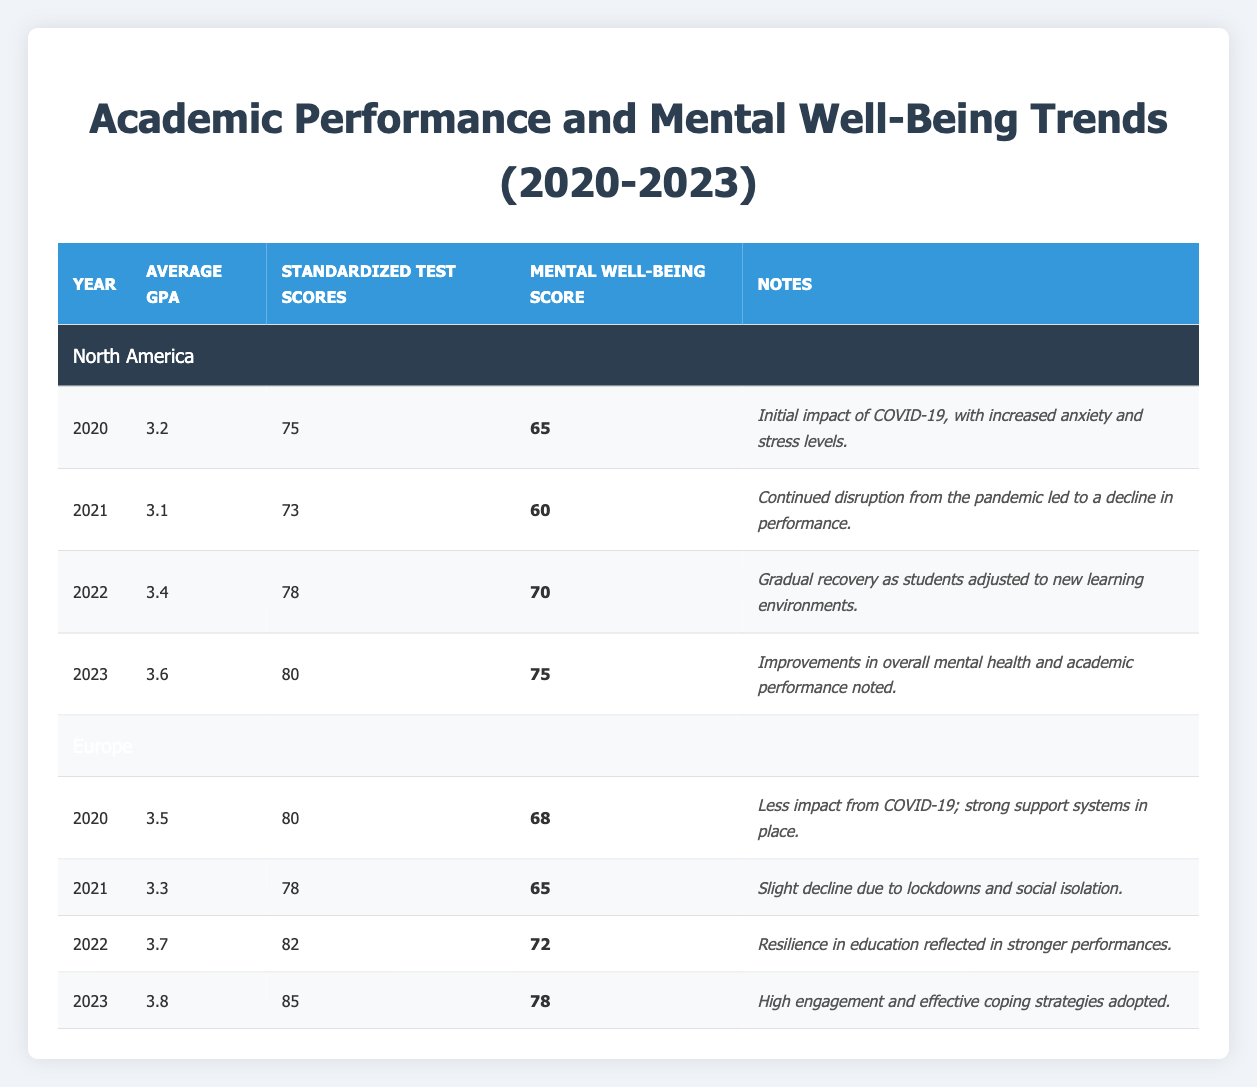What was the Average GPA in Europe in 2021? The table shows that in Europe, the Average GPA for the year 2021 is 3.3. This value can be directly retrieved from the row corresponding to the year 2021 in Europe.
Answer: 3.3 What is the difference in Standardized Test Scores between North America in 2020 and 2023? In 2020, North America's Standardized Test Scores were 75, while in 2023, they increased to 80. The difference is calculated as 80 - 75 = 5.
Answer: 5 Did the Mental Well-Being Score in North America improve from 2020 to 2023? To determine this, we look at the Mental Well-Being Scores for both years: 2020 has a score of 65, and 2023 has a score of 75. Since 75 is greater than 65, we can conclude that it did improve.
Answer: Yes What was the Average GPA trend in North America from 2020 to 2023? The Average GPA values for North America from 2020 to 2023 are as follows: 3.2 (2020), 3.1 (2021), 3.4 (2022), and 3.6 (2023). The trend shows a decrease from 2020 to 2021, followed by an increase in the following years, culminating in 3.6 in 2023.
Answer: Decreased then increased What is the highest Standardized Test Score recorded in Europe from 2020 to 2023? Reviewing the data, the Standardized Test Scores for Europe across the years are: 80 (2020), 78 (2021), 82 (2022), and 85 (2023). The highest score among these is 85, which occurred in 2023.
Answer: 85 What are the average Mental Well-Being Scores for North America and Europe in 2022? For North America, the Mental Well-Being Score in 2022 is 70, and for Europe, it is 72. To find the average of these two scores, we add them together: 70 + 72 = 142, then divide by 2: 142 / 2 = 71.
Answer: 71 Was there a year when North America had a higher Average GPA compared to Europe? Comparing the Average GPA of North America and Europe for each year: 2020 (3.2 vs 3.5), 2021 (3.1 vs 3.3), 2022 (3.4 vs 3.7), and 2023 (3.6 vs 3.8). In all four years, Europe had a higher Average GPA.
Answer: No How much did the Average GPA increase from 2021 to 2022 in Europe? The Average GPA in Europe was 3.3 in 2021 and 3.7 in 2022. We can calculate the increase by subtracting the 2021 value from the 2022 value: 3.7 - 3.3 = 0.4.
Answer: 0.4 What was the Mental Well-Being Score in Europe in 2020, and how does it compare to the score in 2023? The Mental Well-Being Score in Europe for 2020 was 68, and for 2023 it is 78. To compare, we see that 78 is higher than 68, indicating an increase.
Answer: It increased from 68 to 78 